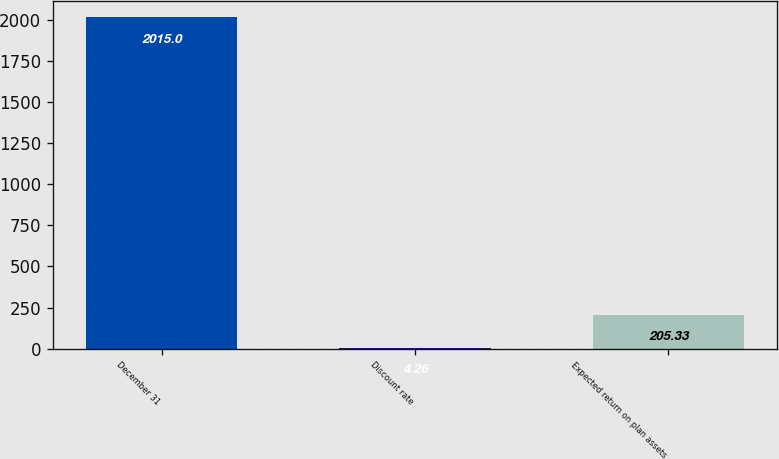<chart> <loc_0><loc_0><loc_500><loc_500><bar_chart><fcel>December 31<fcel>Discount rate<fcel>Expected return on plan assets<nl><fcel>2015<fcel>4.26<fcel>205.33<nl></chart> 